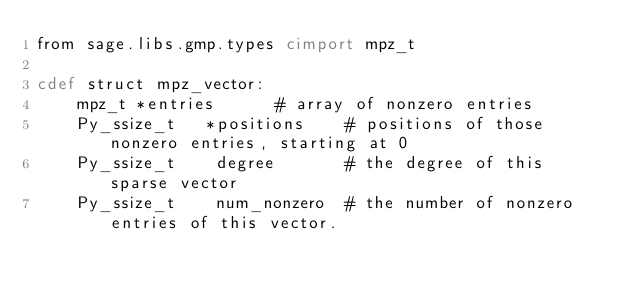Convert code to text. <code><loc_0><loc_0><loc_500><loc_500><_Cython_>from sage.libs.gmp.types cimport mpz_t

cdef struct mpz_vector:
    mpz_t *entries      # array of nonzero entries
    Py_ssize_t   *positions    # positions of those nonzero entries, starting at 0
    Py_ssize_t    degree       # the degree of this sparse vector
    Py_ssize_t    num_nonzero  # the number of nonzero entries of this vector.

</code> 